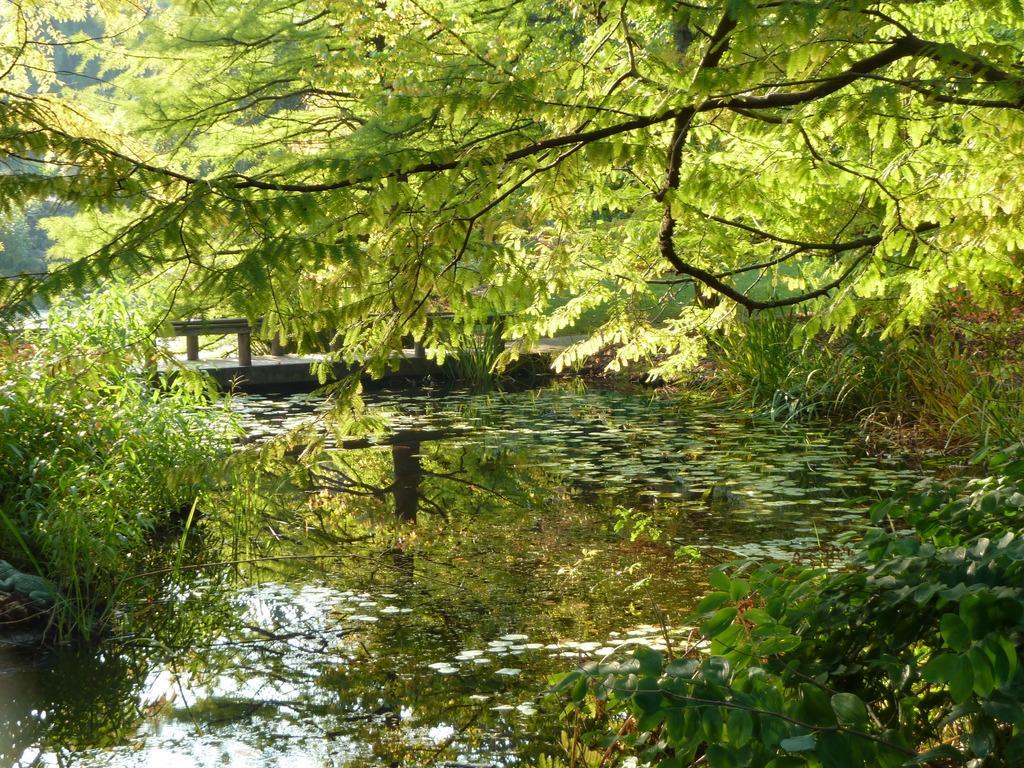In one or two sentences, can you explain what this image depicts? In this image in front there is water. In the center of the image there is a bridge. There are plants and trees. 